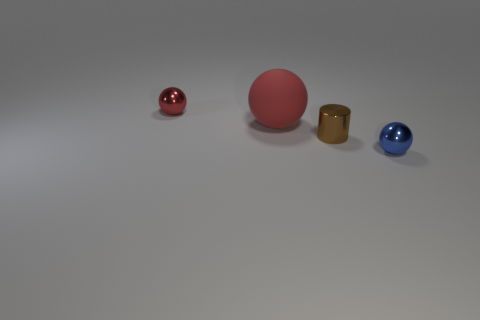Add 2 blue metal things. How many objects exist? 6 Subtract all cylinders. How many objects are left? 3 Add 4 tiny shiny things. How many tiny shiny things exist? 7 Subtract 1 brown cylinders. How many objects are left? 3 Subtract all matte things. Subtract all brown shiny objects. How many objects are left? 2 Add 2 tiny brown cylinders. How many tiny brown cylinders are left? 3 